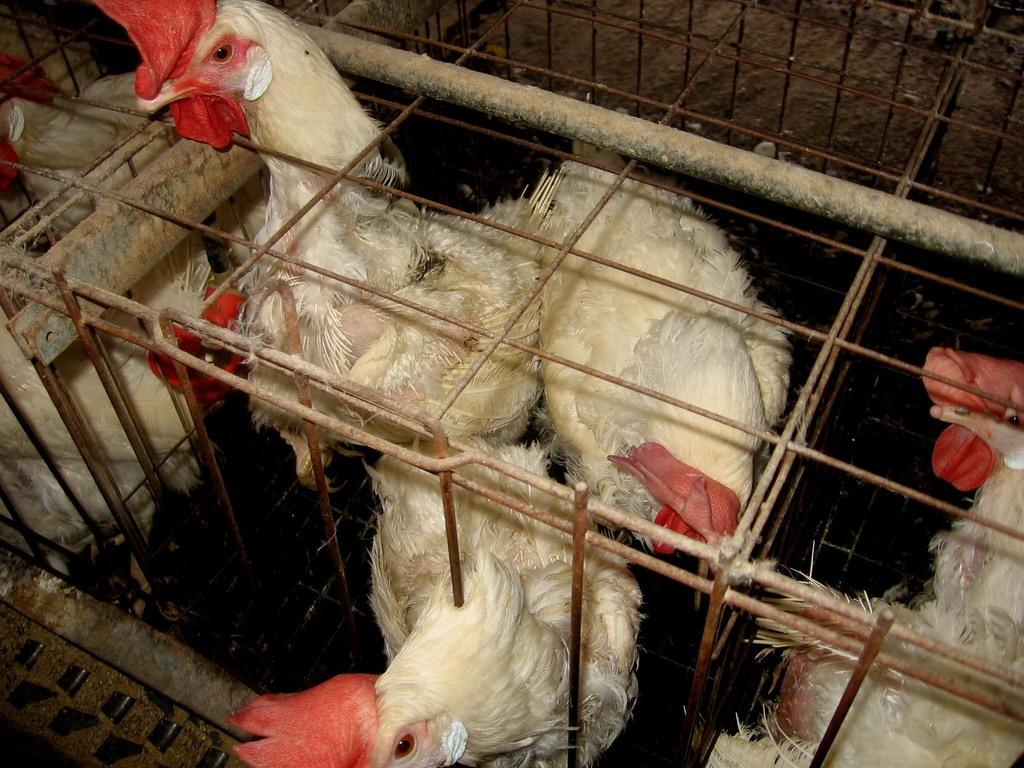What type of animals are in the image? There are hens in the image. Where are the hens located? The hens are in a cage. Can you describe the position of the hens in the image? The hens are in the center of the image. What type of plant is growing in the center of the image? There is no plant present in the image; it features hens in a cage. What letters can be seen on the hens in the image? There are no letters on the hens in the image. 